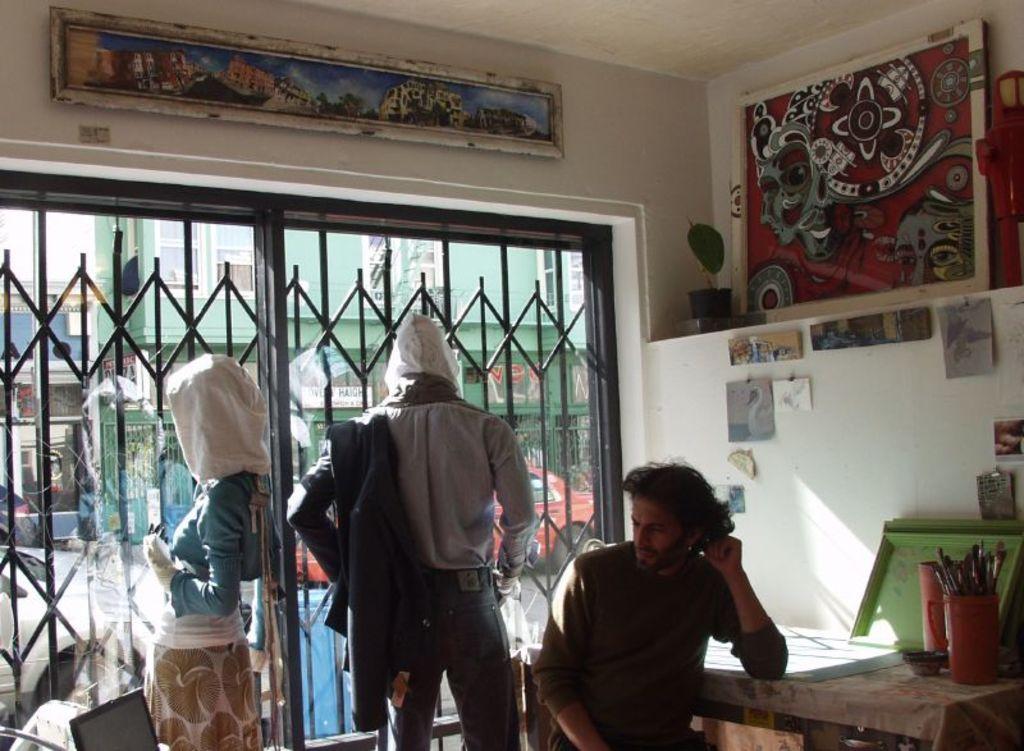Could you give a brief overview of what you see in this image? Picture of a inside room. Photos are attached to this wall. This is a gate. This are buildings with windows. This 2 persons are standing. This person is sitting beside this table. On this table there are things. This person is holding a jacket. Vehicle on road. 